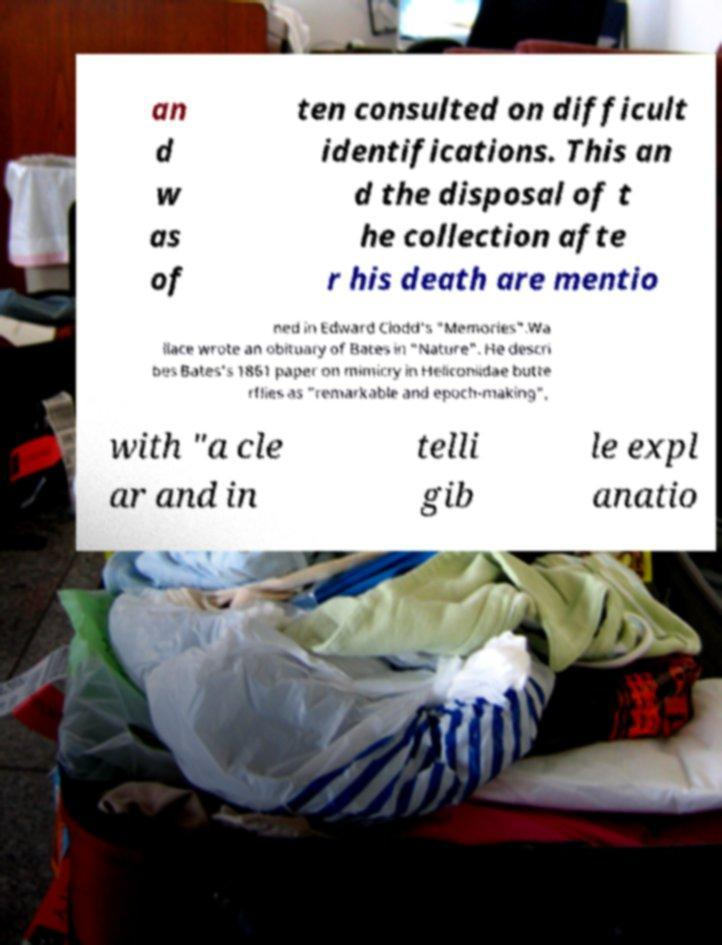Please identify and transcribe the text found in this image. an d w as of ten consulted on difficult identifications. This an d the disposal of t he collection afte r his death are mentio ned in Edward Clodd's "Memories".Wa llace wrote an obituary of Bates in "Nature". He descri bes Bates's 1861 paper on mimicry in Heliconiidae butte rflies as "remarkable and epoch-making", with "a cle ar and in telli gib le expl anatio 